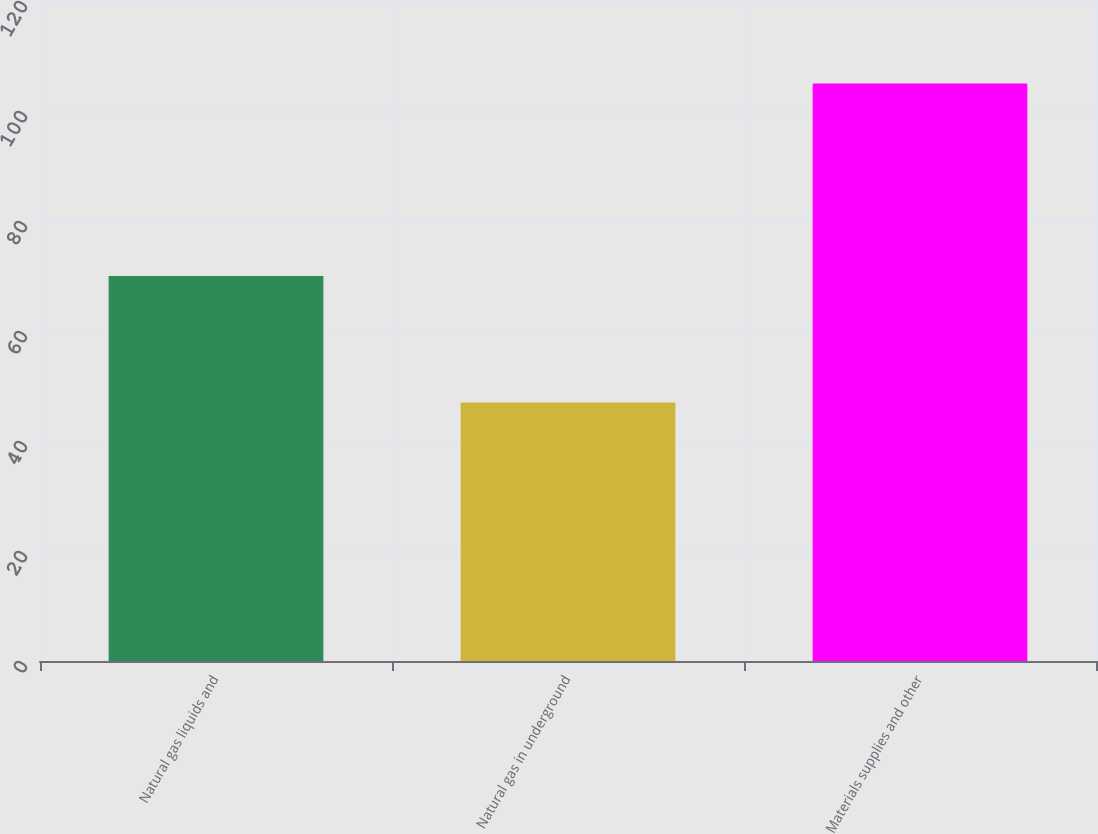Convert chart. <chart><loc_0><loc_0><loc_500><loc_500><bar_chart><fcel>Natural gas liquids and<fcel>Natural gas in underground<fcel>Materials supplies and other<nl><fcel>70<fcel>47<fcel>105<nl></chart> 